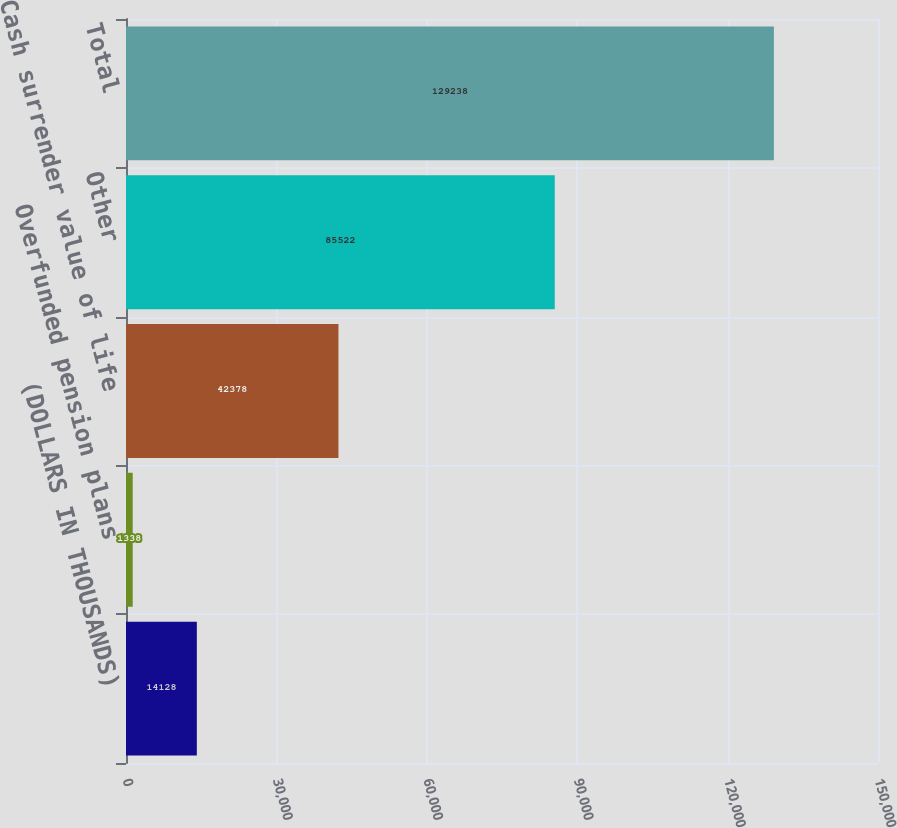Convert chart to OTSL. <chart><loc_0><loc_0><loc_500><loc_500><bar_chart><fcel>(DOLLARS IN THOUSANDS)<fcel>Overfunded pension plans<fcel>Cash surrender value of life<fcel>Other<fcel>Total<nl><fcel>14128<fcel>1338<fcel>42378<fcel>85522<fcel>129238<nl></chart> 